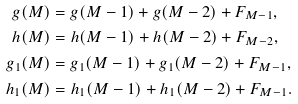Convert formula to latex. <formula><loc_0><loc_0><loc_500><loc_500>g ( M ) & = g ( M - 1 ) + g ( M - 2 ) + F _ { M - 1 } , \\ h ( M ) & = h ( M - 1 ) + h ( M - 2 ) + F _ { M - 2 } , \\ g _ { 1 } ( M ) & = g _ { 1 } ( M - 1 ) + g _ { 1 } ( M - 2 ) + F _ { M - 1 } , \\ h _ { 1 } ( M ) & = h _ { 1 } ( M - 1 ) + h _ { 1 } ( M - 2 ) + F _ { M - 1 } .</formula> 